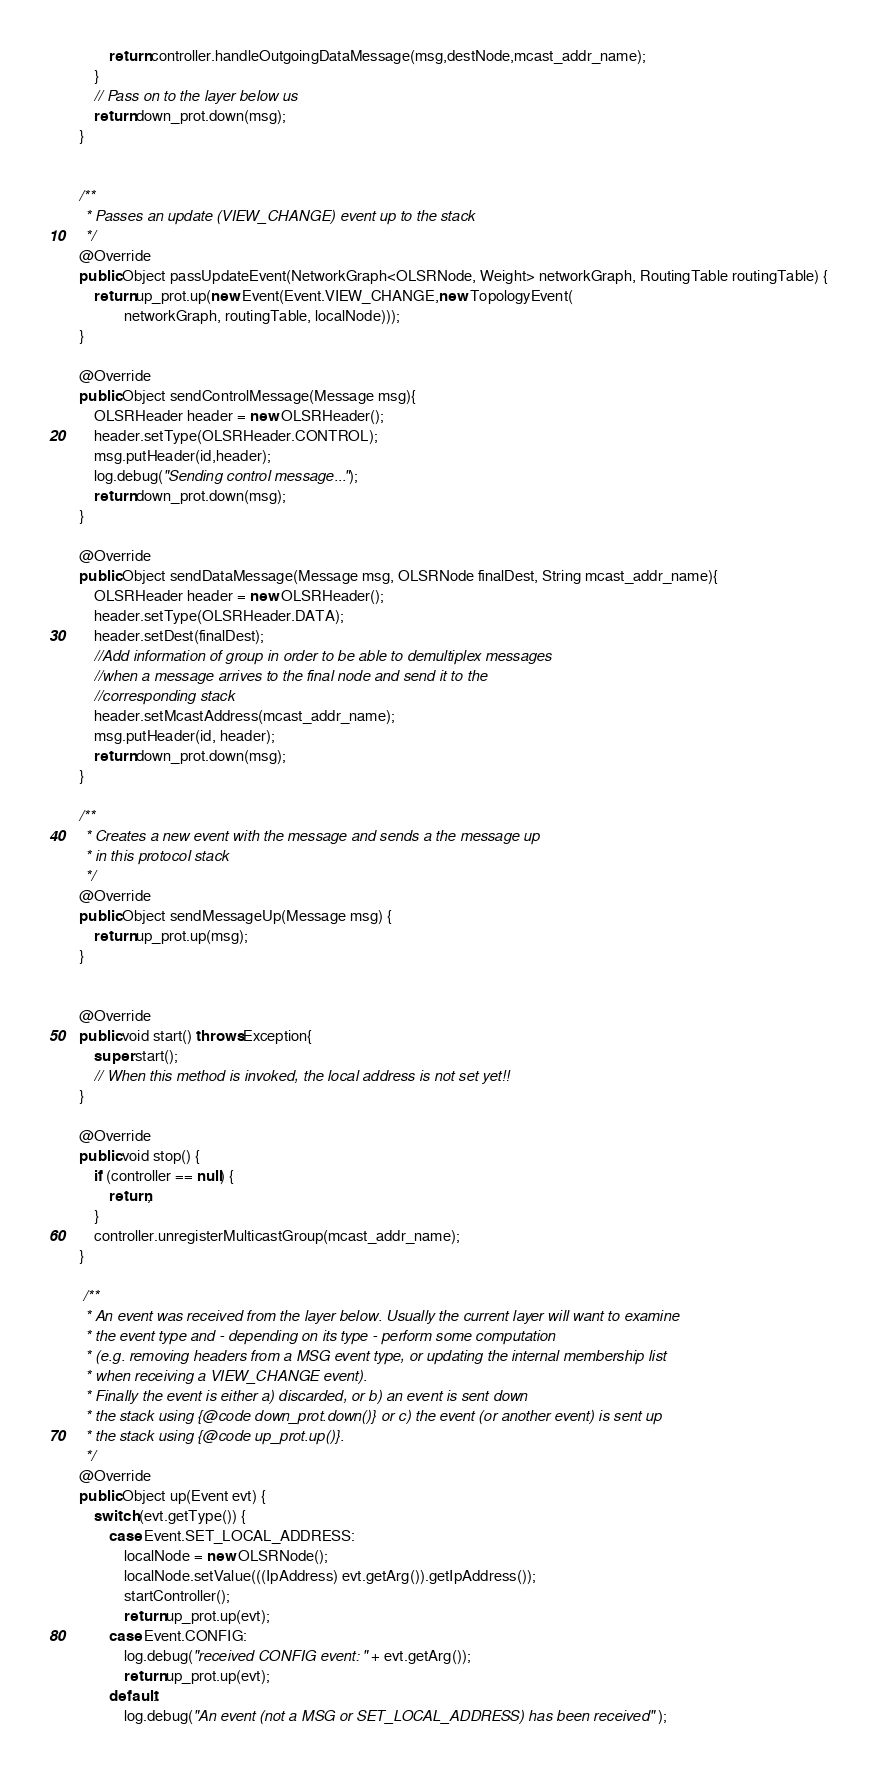<code> <loc_0><loc_0><loc_500><loc_500><_Java_>            return controller.handleOutgoingDataMessage(msg,destNode,mcast_addr_name);
        }
        // Pass on to the layer below us
        return down_prot.down(msg);
    }


	/**
	 * Passes an update (VIEW_CHANGE) event up to the stack
	 */
	@Override
	public Object passUpdateEvent(NetworkGraph<OLSRNode, Weight> networkGraph, RoutingTable routingTable) {
		return up_prot.up(new Event(Event.VIEW_CHANGE,new TopologyEvent(
				networkGraph, routingTable, localNode)));
	}
	
	@Override
	public Object sendControlMessage(Message msg){
		OLSRHeader header = new OLSRHeader();
		header.setType(OLSRHeader.CONTROL);
		msg.putHeader(id,header);
		log.debug("Sending control message...");
		return down_prot.down(msg);
	}
	
	@Override
	public Object sendDataMessage(Message msg, OLSRNode finalDest, String mcast_addr_name){
		OLSRHeader header = new OLSRHeader();
		header.setType(OLSRHeader.DATA);
		header.setDest(finalDest);
		//Add information of group in order to be able to demultiplex messages
		//when a message arrives to the final node and send it to the
		//corresponding stack
		header.setMcastAddress(mcast_addr_name);
		msg.putHeader(id, header);
		return down_prot.down(msg);
	}
	
	/**
	 * Creates a new event with the message and sends a the message up
	 * in this protocol stack
	 */
	@Override
	public Object sendMessageUp(Message msg) {
		return up_prot.up(msg);
	}


	@Override
	public void start() throws Exception{
		super.start();
		// When this method is invoked, the local address is not set yet!!
	}
	
	@Override
	public void stop() {
		if (controller == null) {
			return;
		}
		controller.unregisterMulticastGroup(mcast_addr_name);
	}

	 /**
     * An event was received from the layer below. Usually the current layer will want to examine
     * the event type and - depending on its type - perform some computation
     * (e.g. removing headers from a MSG event type, or updating the internal membership list
     * when receiving a VIEW_CHANGE event).
     * Finally the event is either a) discarded, or b) an event is sent down
     * the stack using {@code down_prot.down()} or c) the event (or another event) is sent up
     * the stack using {@code up_prot.up()}.
     */
	@Override
	public Object up(Event evt) {
        switch (evt.getType()) {
            case Event.SET_LOCAL_ADDRESS:
                localNode = new OLSRNode();
                localNode.setValue(((IpAddress) evt.getArg()).getIpAddress());
                startController();
                return up_prot.up(evt);
            case Event.CONFIG:
                log.debug("received CONFIG event: " + evt.getArg());
                return up_prot.up(evt);
            default:
                log.debug("An event (not a MSG or SET_LOCAL_ADDRESS) has been received" );</code> 